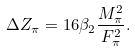Convert formula to latex. <formula><loc_0><loc_0><loc_500><loc_500>\Delta Z _ { \pi } = 1 6 \beta _ { 2 } \frac { M ^ { 2 } _ { \pi } } { F ^ { 2 } _ { \pi } } .</formula> 